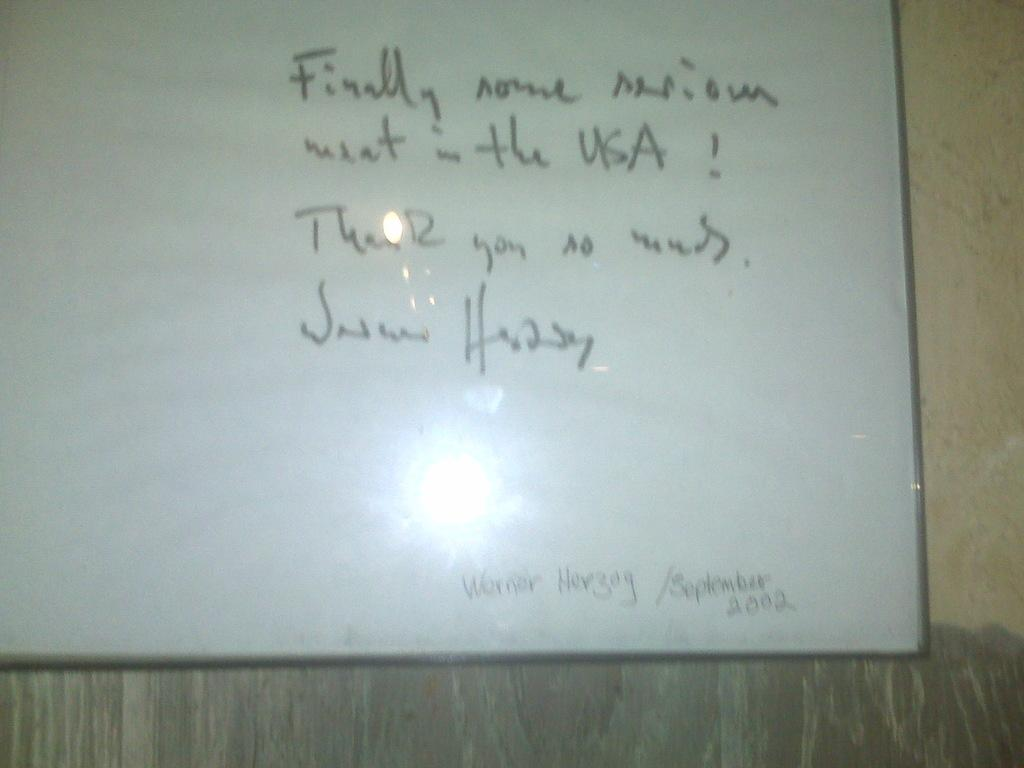Provide a one-sentence caption for the provided image. A thank you message that is written on a board. 